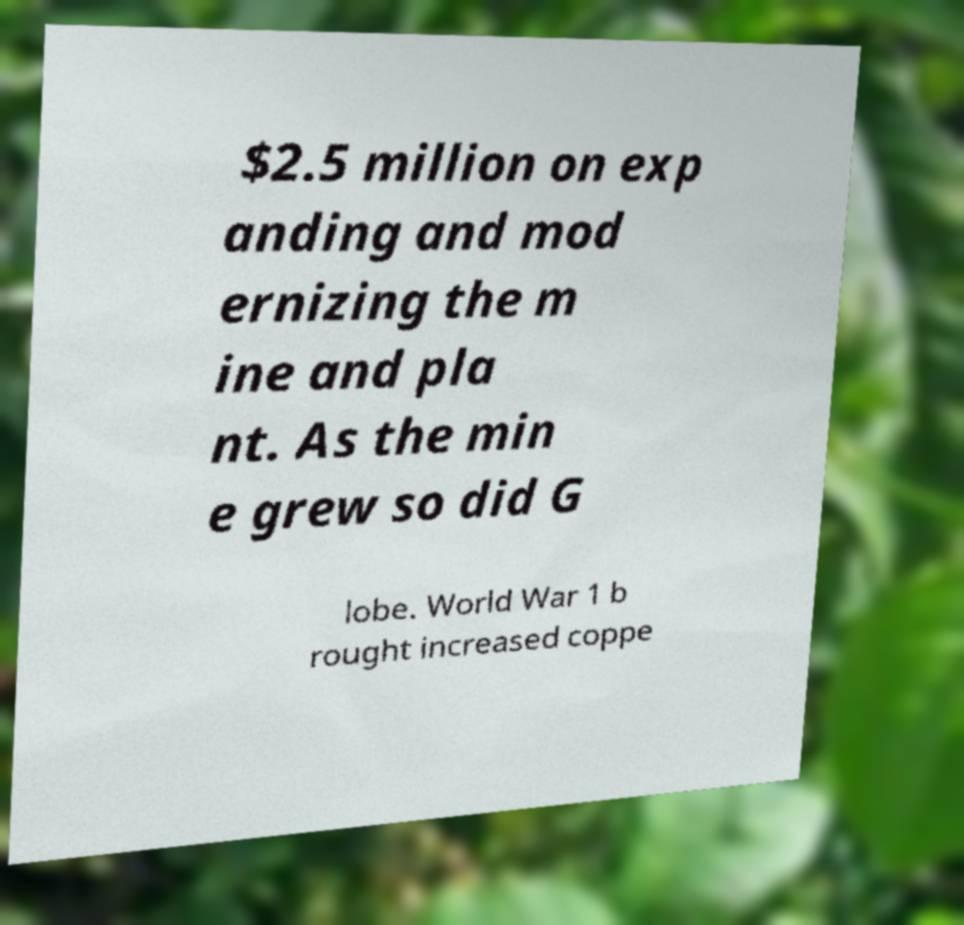What messages or text are displayed in this image? I need them in a readable, typed format. $2.5 million on exp anding and mod ernizing the m ine and pla nt. As the min e grew so did G lobe. World War 1 b rought increased coppe 